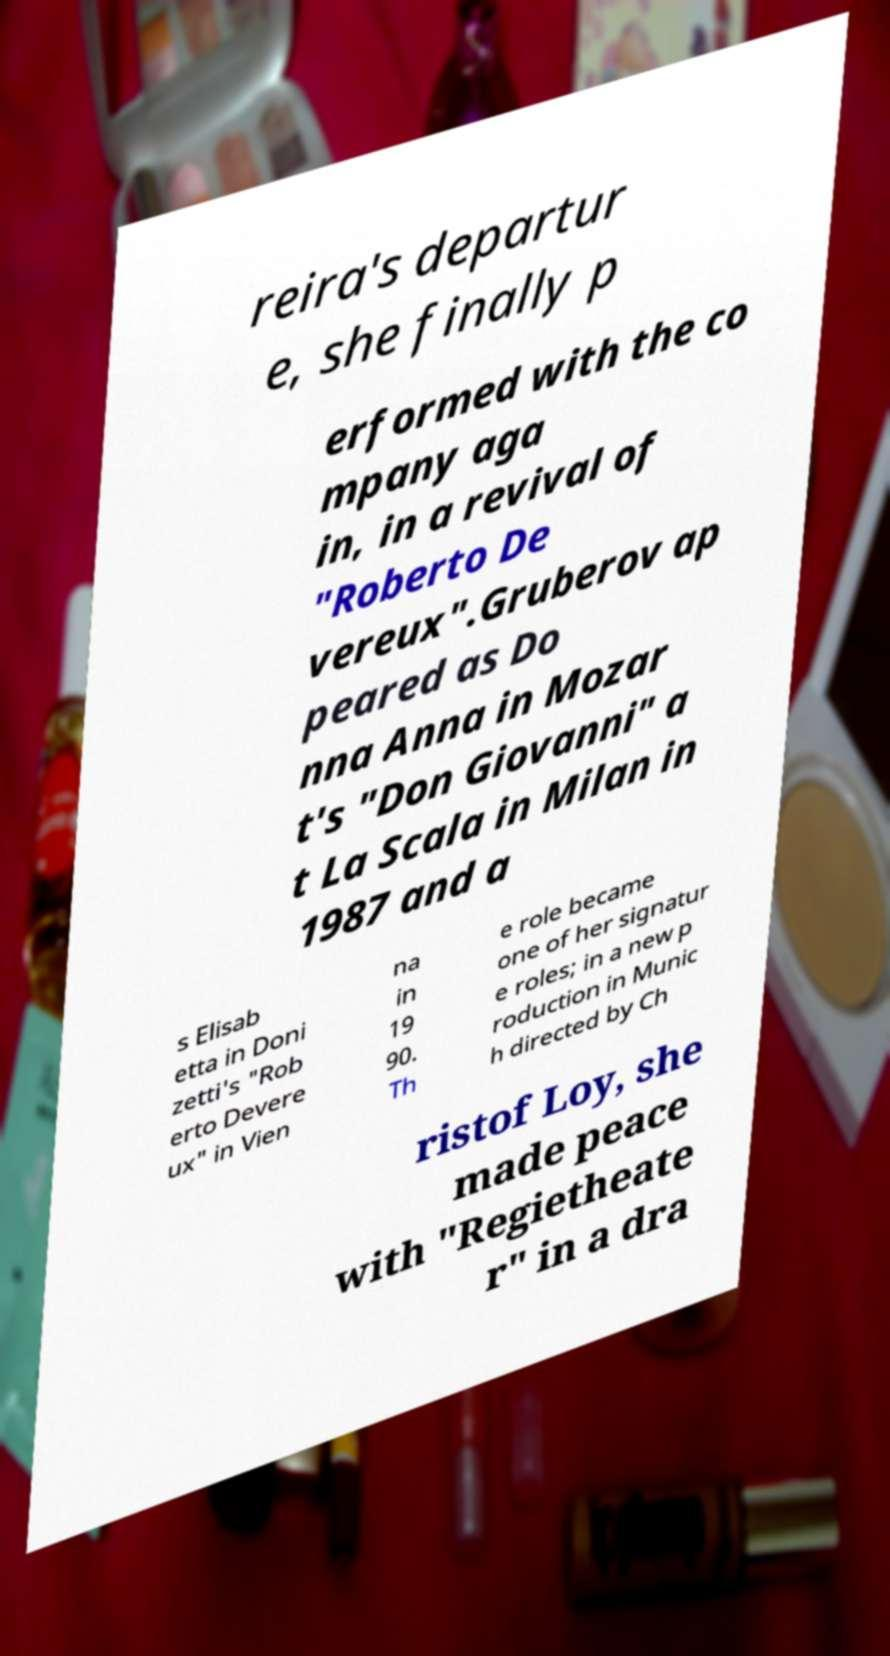Please read and relay the text visible in this image. What does it say? reira's departur e, she finally p erformed with the co mpany aga in, in a revival of "Roberto De vereux".Gruberov ap peared as Do nna Anna in Mozar t's "Don Giovanni" a t La Scala in Milan in 1987 and a s Elisab etta in Doni zetti's "Rob erto Devere ux" in Vien na in 19 90. Th e role became one of her signatur e roles; in a new p roduction in Munic h directed by Ch ristof Loy, she made peace with "Regietheate r" in a dra 